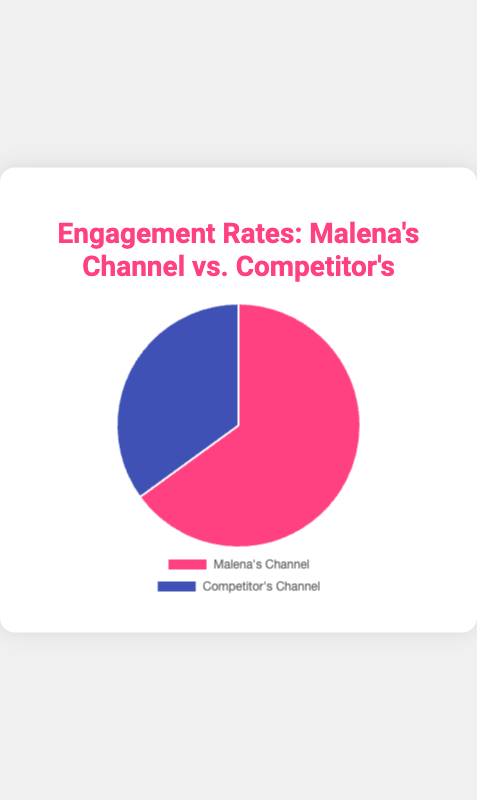What is the engagement rate on Malena's Channel? The pie chart shows that Malena's Channel has an engagement rate of 65%. Simply look at the segment labeled "Malena's Channel".
Answer: 65% What is the engagement rate on the Competitor's Channel? The pie chart shows that the Competitor's Channel has an engagement rate of 35%. Simply look at the segment labeled "Competitor's Channel".
Answer: 35% Which channel has a higher engagement rate? Compare the percentage values of the two segments. Malena's Channel (65%) has a higher engagement rate compared to the Competitor's Channel (35%).
Answer: Malena's Channel By how much does Malena's Channel's engagement rate exceed the Competitor's Channel's engagement rate? Subtract the engagement rate of the Competitor's Channel (35%) from that of Malena's Channel (65%). That is, 65% - 35% = 30%.
Answer: 30% What percentage of the total engagement is accounted for by Malena's Channel? Malena's Channel accounts for 65% of the total engagement as shown in the pie chart.
Answer: 65% Is the engagement rate on the Competitor's Channel more than half of Malena's Channel? Compare 35% (Competitor's Channel) with half of 65% (Malena's Channel), which is 32.5%. Since 35% is greater than 32.5%, the Competitor's Channel's engagement rate is more than half of Malena's.
Answer: Yes What is the color used to represent Malena's Channel in the pie chart? The pie chart visually represents Malena's Channel with the color pink.
Answer: Pink What fraction of the total engagement does the Competitor's Channel represent? The Competitor's Channel has an engagement rate of 35%. Convert this percentage to a fraction: 35/100 = 7/20.
Answer: 7/20 